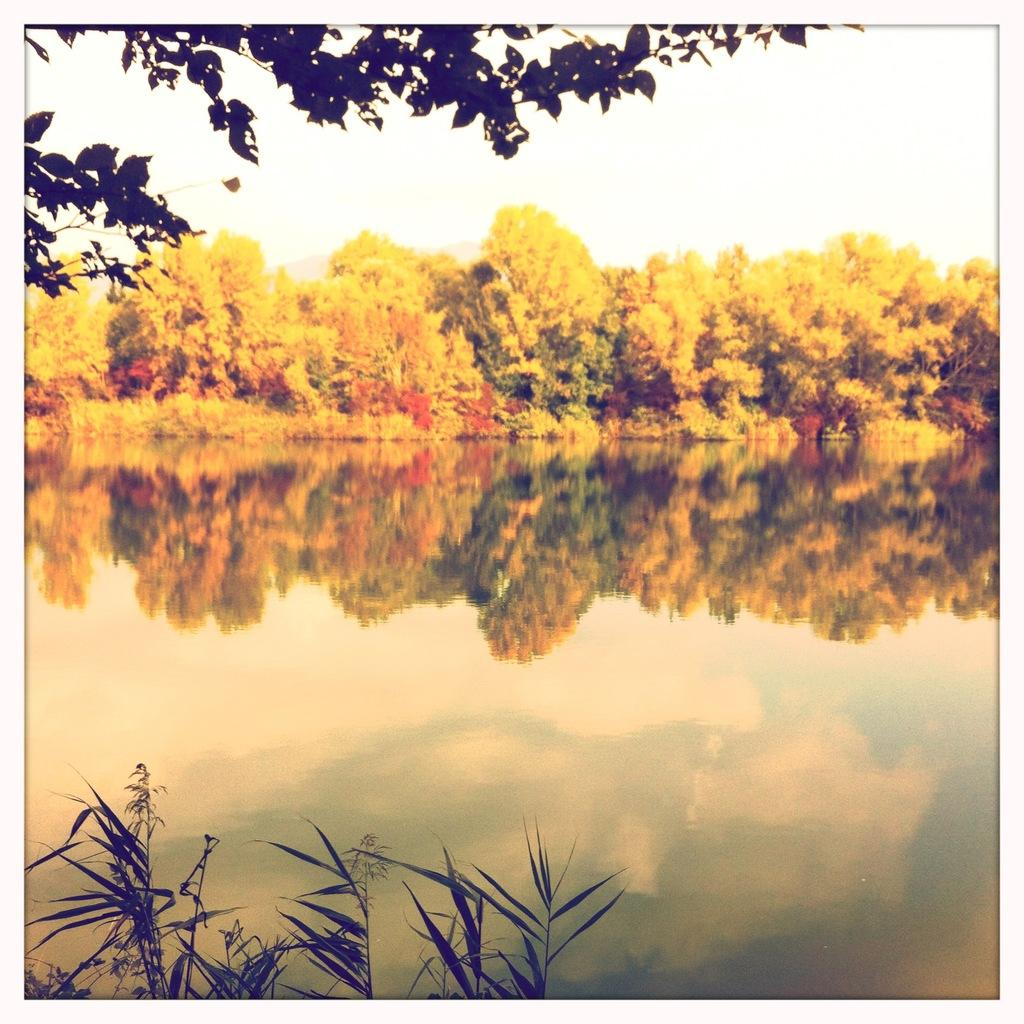What is the primary element present in the image? There is water in the image. What type of vegetation can be seen in the image? There are trees visible in the image. What is the condition of the sky in the image? The sky is clear in the image. How many crates are stacked on top of the giants in the image? There are no crates or giants present in the image. Can you describe the horse's mane in the image? There is no horse present in the image. 